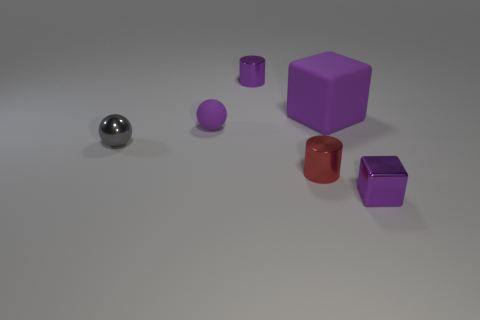Subtract all purple cubes. How many were subtracted if there are1purple cubes left? 1 Add 1 big purple objects. How many objects exist? 7 Subtract all cubes. How many objects are left? 4 Subtract all gray balls. How many balls are left? 1 Subtract 2 balls. How many balls are left? 0 Subtract all green blocks. Subtract all yellow cylinders. How many blocks are left? 2 Subtract all green cylinders. How many gray balls are left? 1 Subtract all tiny red metallic cylinders. Subtract all red shiny things. How many objects are left? 4 Add 1 small red cylinders. How many small red cylinders are left? 2 Add 1 blue metallic blocks. How many blue metallic blocks exist? 1 